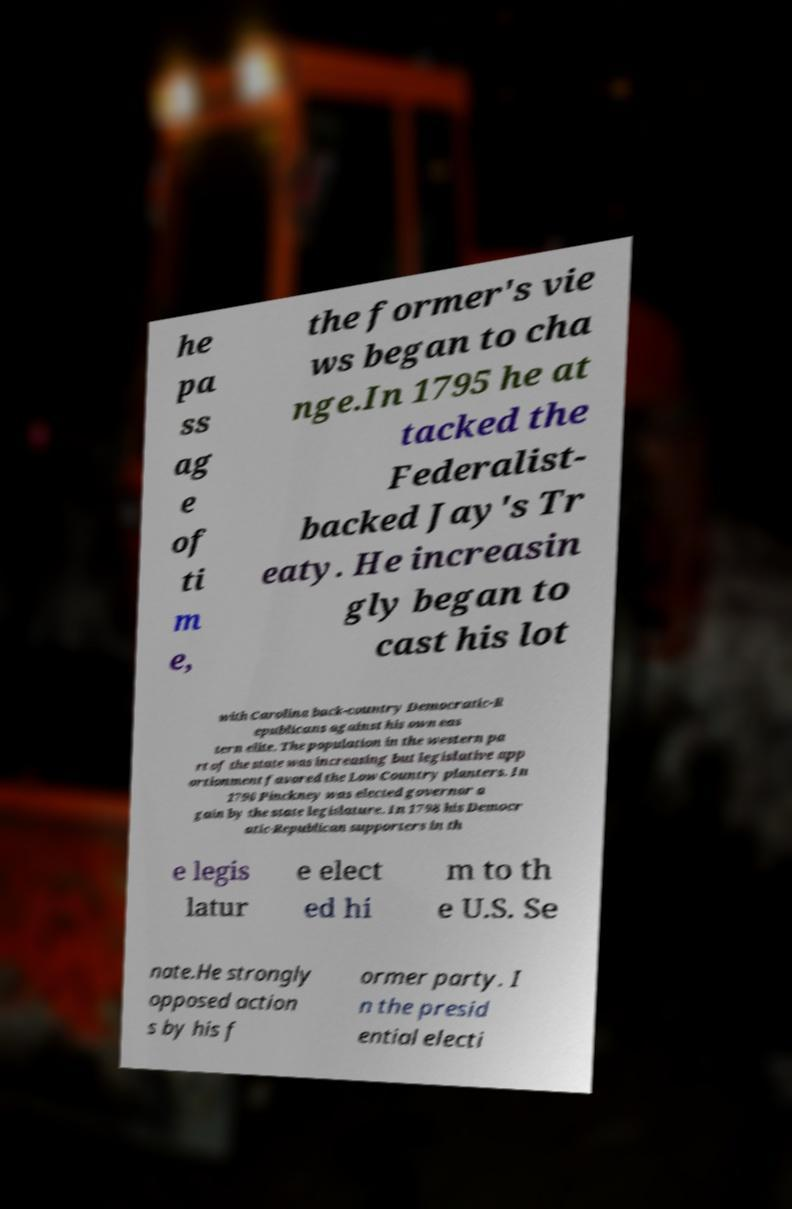Could you assist in decoding the text presented in this image and type it out clearly? he pa ss ag e of ti m e, the former's vie ws began to cha nge.In 1795 he at tacked the Federalist- backed Jay's Tr eaty. He increasin gly began to cast his lot with Carolina back-country Democratic-R epublicans against his own eas tern elite. The population in the western pa rt of the state was increasing but legislative app ortionment favored the Low Country planters. In 1796 Pinckney was elected governor a gain by the state legislature. In 1798 his Democr atic-Republican supporters in th e legis latur e elect ed hi m to th e U.S. Se nate.He strongly opposed action s by his f ormer party. I n the presid ential electi 